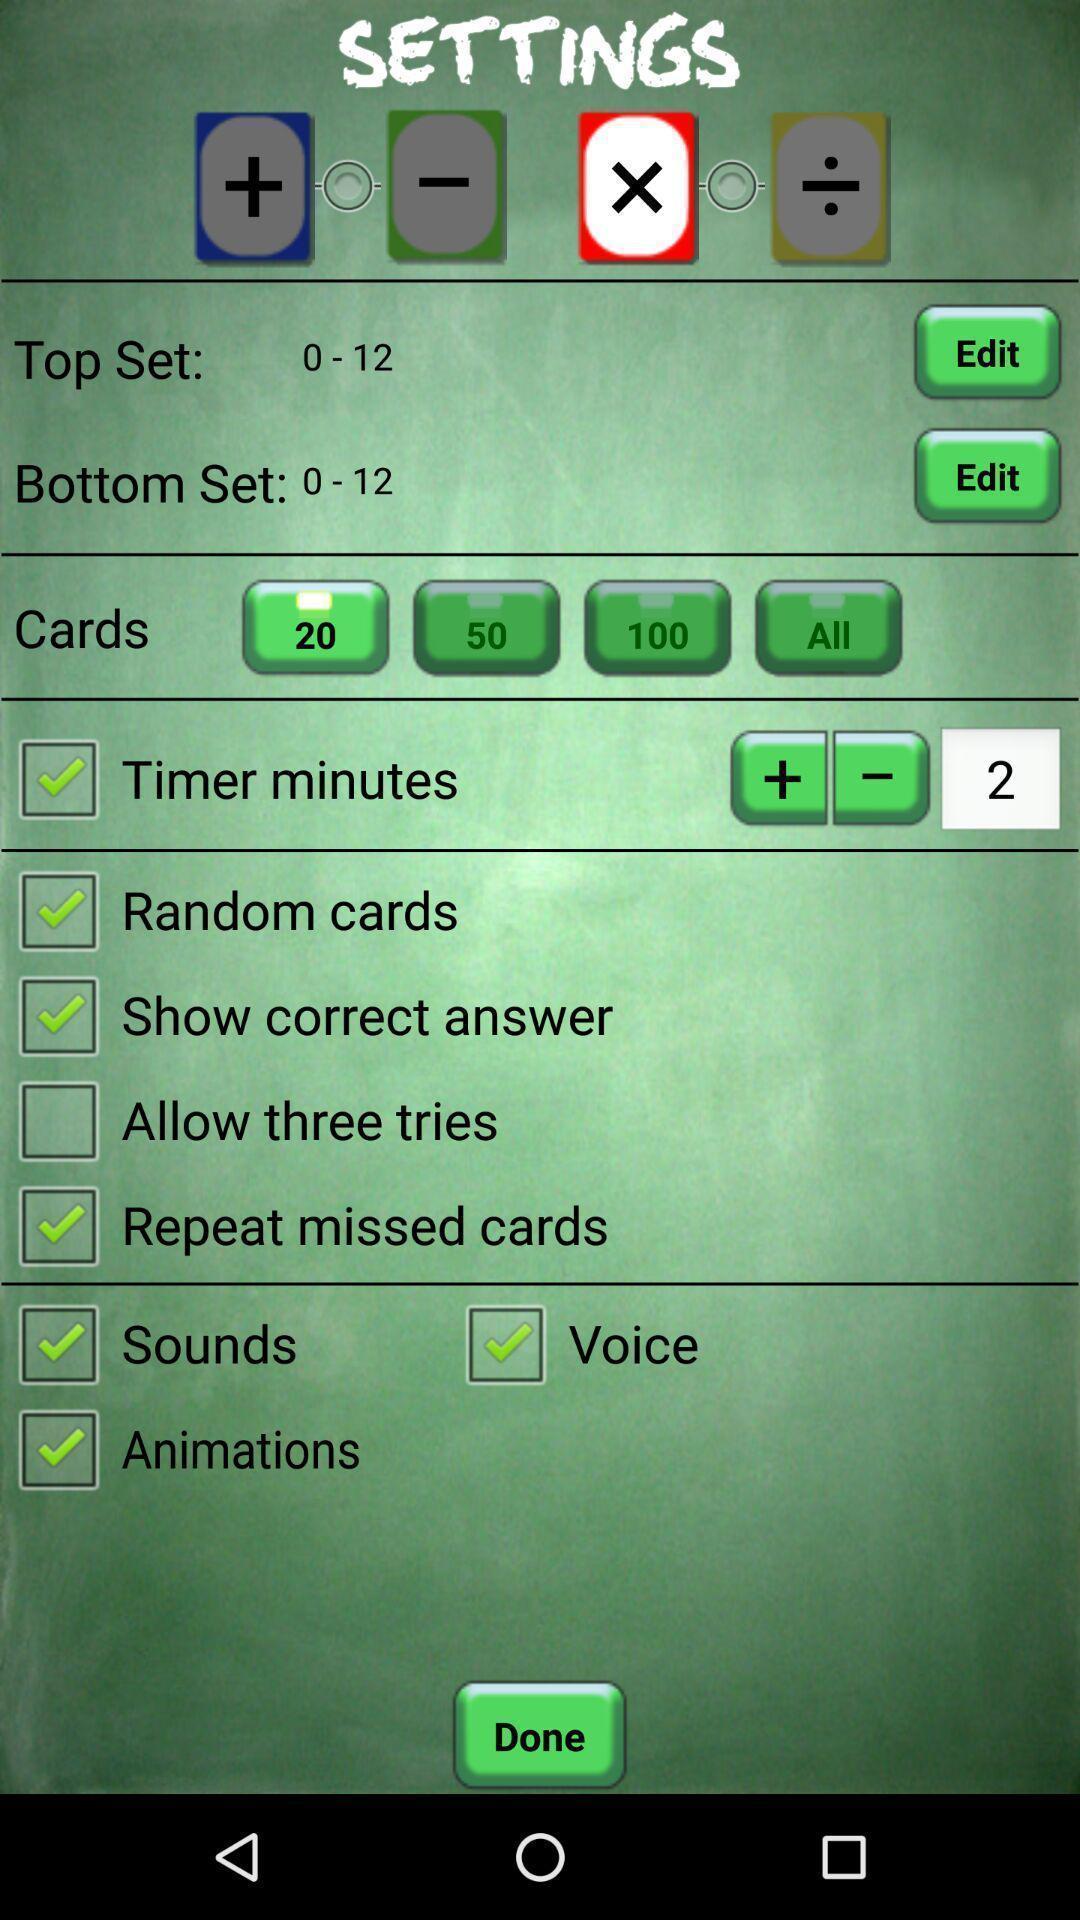Give me a summary of this screen capture. Page displaying multiple settings options. 